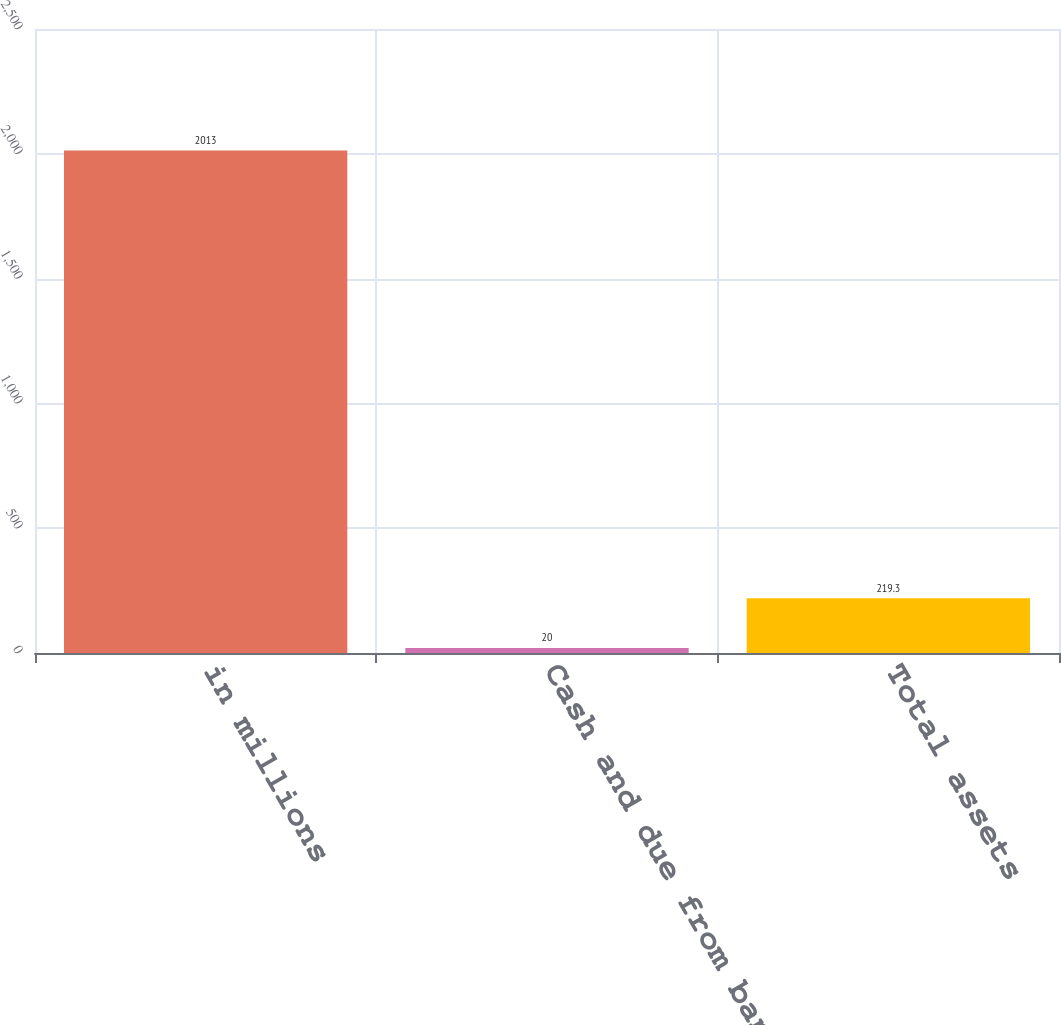Convert chart to OTSL. <chart><loc_0><loc_0><loc_500><loc_500><bar_chart><fcel>in millions<fcel>Cash and due from banks<fcel>Total assets<nl><fcel>2013<fcel>20<fcel>219.3<nl></chart> 